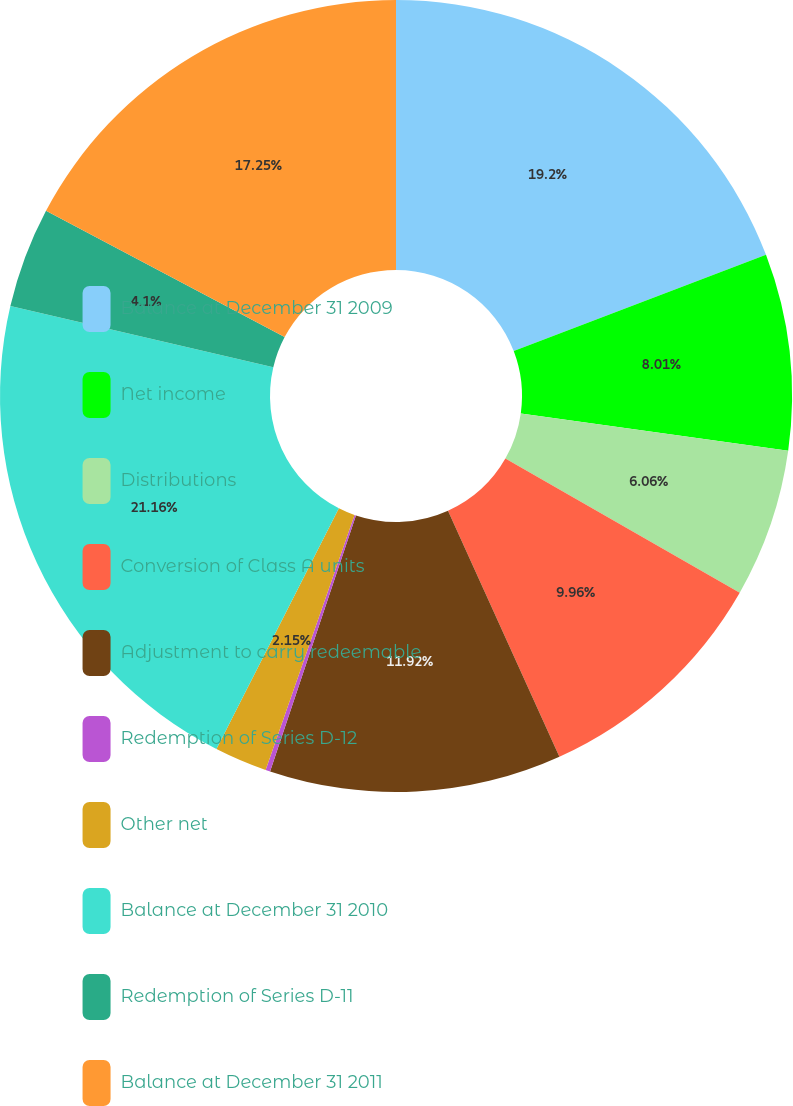<chart> <loc_0><loc_0><loc_500><loc_500><pie_chart><fcel>Balance at December 31 2009<fcel>Net income<fcel>Distributions<fcel>Conversion of Class A units<fcel>Adjustment to carry redeemable<fcel>Redemption of Series D-12<fcel>Other net<fcel>Balance at December 31 2010<fcel>Redemption of Series D-11<fcel>Balance at December 31 2011<nl><fcel>19.2%<fcel>8.01%<fcel>6.06%<fcel>9.96%<fcel>11.92%<fcel>0.19%<fcel>2.15%<fcel>21.16%<fcel>4.1%<fcel>17.25%<nl></chart> 